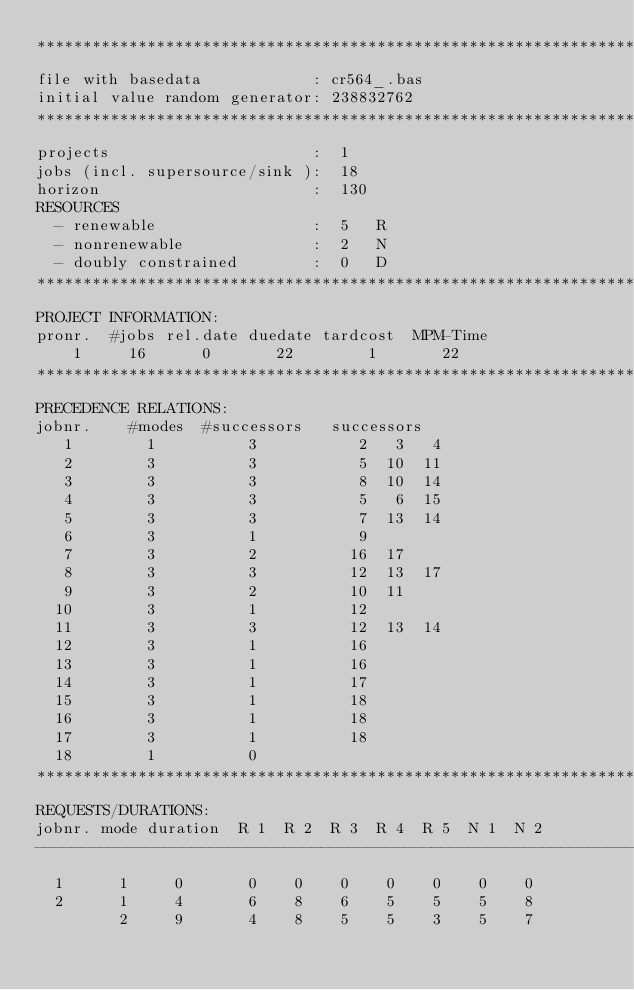<code> <loc_0><loc_0><loc_500><loc_500><_ObjectiveC_>************************************************************************
file with basedata            : cr564_.bas
initial value random generator: 238832762
************************************************************************
projects                      :  1
jobs (incl. supersource/sink ):  18
horizon                       :  130
RESOURCES
  - renewable                 :  5   R
  - nonrenewable              :  2   N
  - doubly constrained        :  0   D
************************************************************************
PROJECT INFORMATION:
pronr.  #jobs rel.date duedate tardcost  MPM-Time
    1     16      0       22        1       22
************************************************************************
PRECEDENCE RELATIONS:
jobnr.    #modes  #successors   successors
   1        1          3           2   3   4
   2        3          3           5  10  11
   3        3          3           8  10  14
   4        3          3           5   6  15
   5        3          3           7  13  14
   6        3          1           9
   7        3          2          16  17
   8        3          3          12  13  17
   9        3          2          10  11
  10        3          1          12
  11        3          3          12  13  14
  12        3          1          16
  13        3          1          16
  14        3          1          17
  15        3          1          18
  16        3          1          18
  17        3          1          18
  18        1          0        
************************************************************************
REQUESTS/DURATIONS:
jobnr. mode duration  R 1  R 2  R 3  R 4  R 5  N 1  N 2
------------------------------------------------------------------------
  1      1     0       0    0    0    0    0    0    0
  2      1     4       6    8    6    5    5    5    8
         2     9       4    8    5    5    3    5    7</code> 